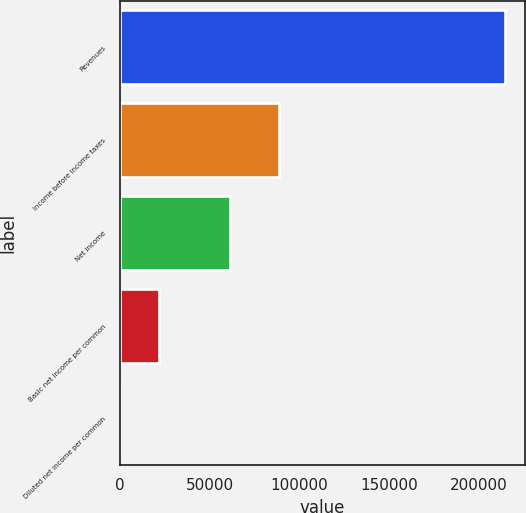Convert chart. <chart><loc_0><loc_0><loc_500><loc_500><bar_chart><fcel>Revenues<fcel>Income before income taxes<fcel>Net income<fcel>Basic net income per common<fcel>Diluted net income per common<nl><fcel>214683<fcel>88361<fcel>61210<fcel>21469.8<fcel>1.62<nl></chart> 